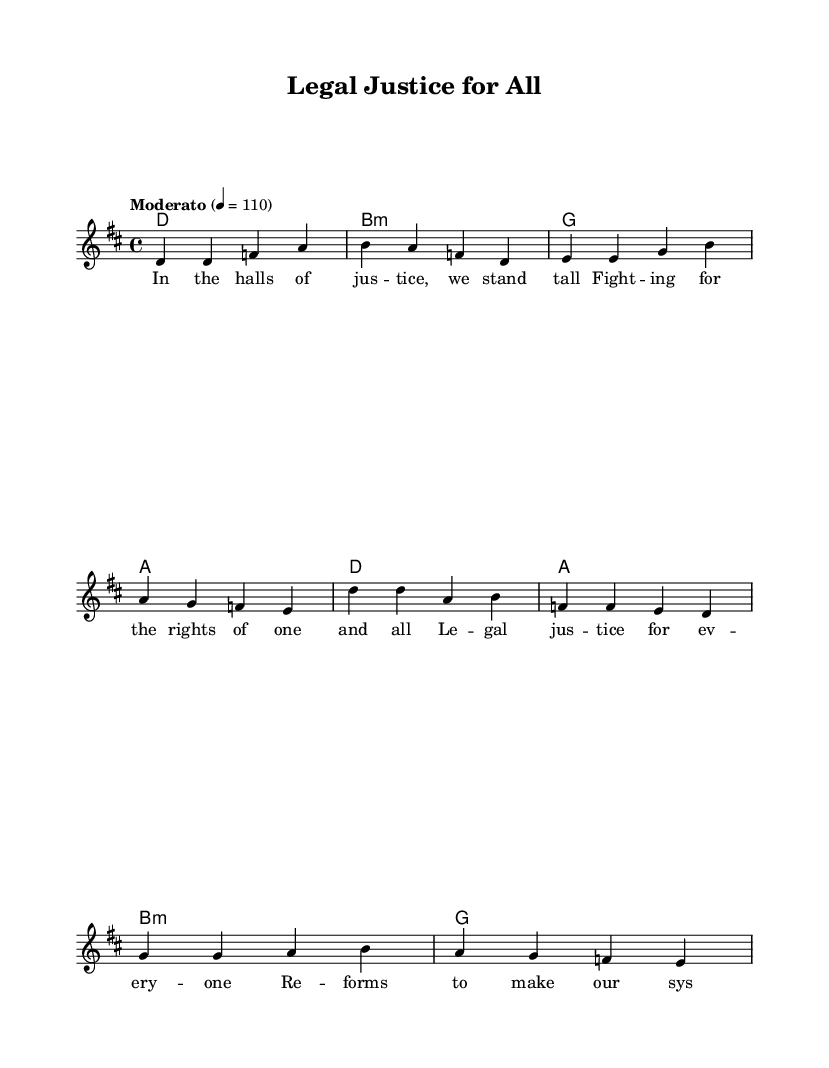What is the key signature of this music? The key signature is D major, which has two sharps (F# and C#). This can be identified at the beginning of the sheet music, where the key signature is indicated before the time signature.
Answer: D major What is the time signature of this music? The time signature is 4/4, which means there are four beats in each measure. This is typically represented at the beginning of the sheet music next to the key signature.
Answer: 4/4 What is the tempo marking of this music? The tempo marking is "Moderato," which indicates a moderate speed. This can be found in the tempo indication at the start of the piece, specifying the pace of the music.
Answer: Moderato What note starts the chorus? The chorus starts on the note D. This can be determined by examining the melody line of the chorus, where the first note is visually identified as D.
Answer: D How many chords are used in the verse? There are four chords used in the verse. By analyzing the chord section corresponding to the verse melody, we can see that each chord is separated by vertical lines and count them.
Answer: 4 What societal issues does this song address? The song addresses legal justice issues. This is evident from the lyrics related to justice and rights, which are focal points in the song's theme.
Answer: Legal justice 